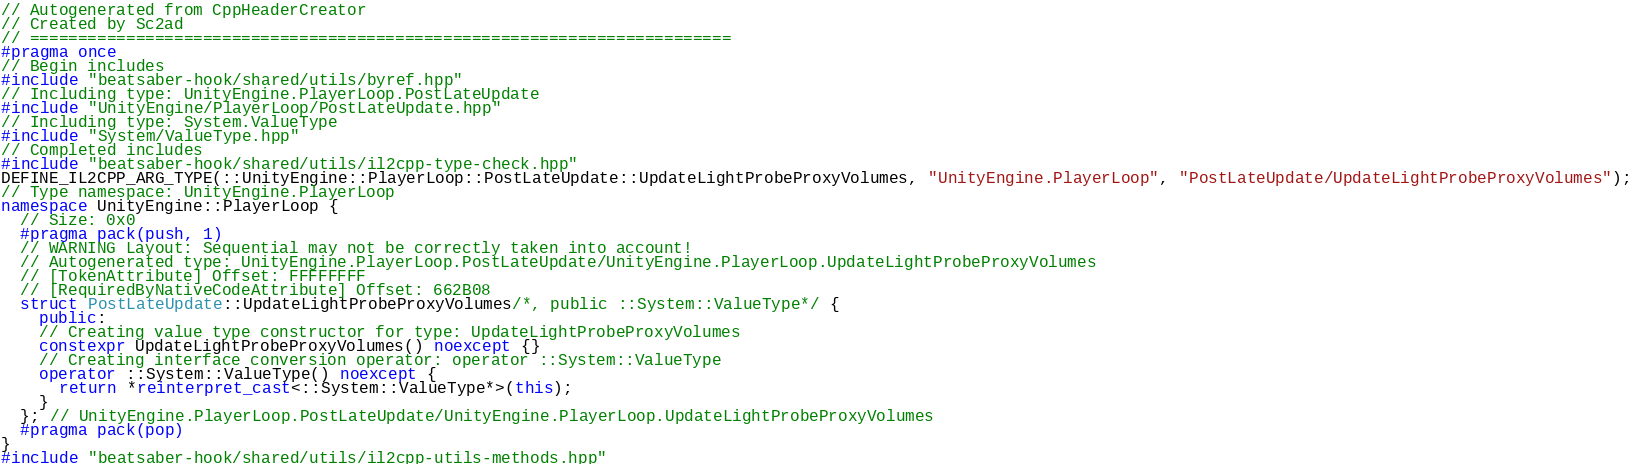<code> <loc_0><loc_0><loc_500><loc_500><_C++_>// Autogenerated from CppHeaderCreator
// Created by Sc2ad
// =========================================================================
#pragma once
// Begin includes
#include "beatsaber-hook/shared/utils/byref.hpp"
// Including type: UnityEngine.PlayerLoop.PostLateUpdate
#include "UnityEngine/PlayerLoop/PostLateUpdate.hpp"
// Including type: System.ValueType
#include "System/ValueType.hpp"
// Completed includes
#include "beatsaber-hook/shared/utils/il2cpp-type-check.hpp"
DEFINE_IL2CPP_ARG_TYPE(::UnityEngine::PlayerLoop::PostLateUpdate::UpdateLightProbeProxyVolumes, "UnityEngine.PlayerLoop", "PostLateUpdate/UpdateLightProbeProxyVolumes");
// Type namespace: UnityEngine.PlayerLoop
namespace UnityEngine::PlayerLoop {
  // Size: 0x0
  #pragma pack(push, 1)
  // WARNING Layout: Sequential may not be correctly taken into account!
  // Autogenerated type: UnityEngine.PlayerLoop.PostLateUpdate/UnityEngine.PlayerLoop.UpdateLightProbeProxyVolumes
  // [TokenAttribute] Offset: FFFFFFFF
  // [RequiredByNativeCodeAttribute] Offset: 662B08
  struct PostLateUpdate::UpdateLightProbeProxyVolumes/*, public ::System::ValueType*/ {
    public:
    // Creating value type constructor for type: UpdateLightProbeProxyVolumes
    constexpr UpdateLightProbeProxyVolumes() noexcept {}
    // Creating interface conversion operator: operator ::System::ValueType
    operator ::System::ValueType() noexcept {
      return *reinterpret_cast<::System::ValueType*>(this);
    }
  }; // UnityEngine.PlayerLoop.PostLateUpdate/UnityEngine.PlayerLoop.UpdateLightProbeProxyVolumes
  #pragma pack(pop)
}
#include "beatsaber-hook/shared/utils/il2cpp-utils-methods.hpp"
</code> 